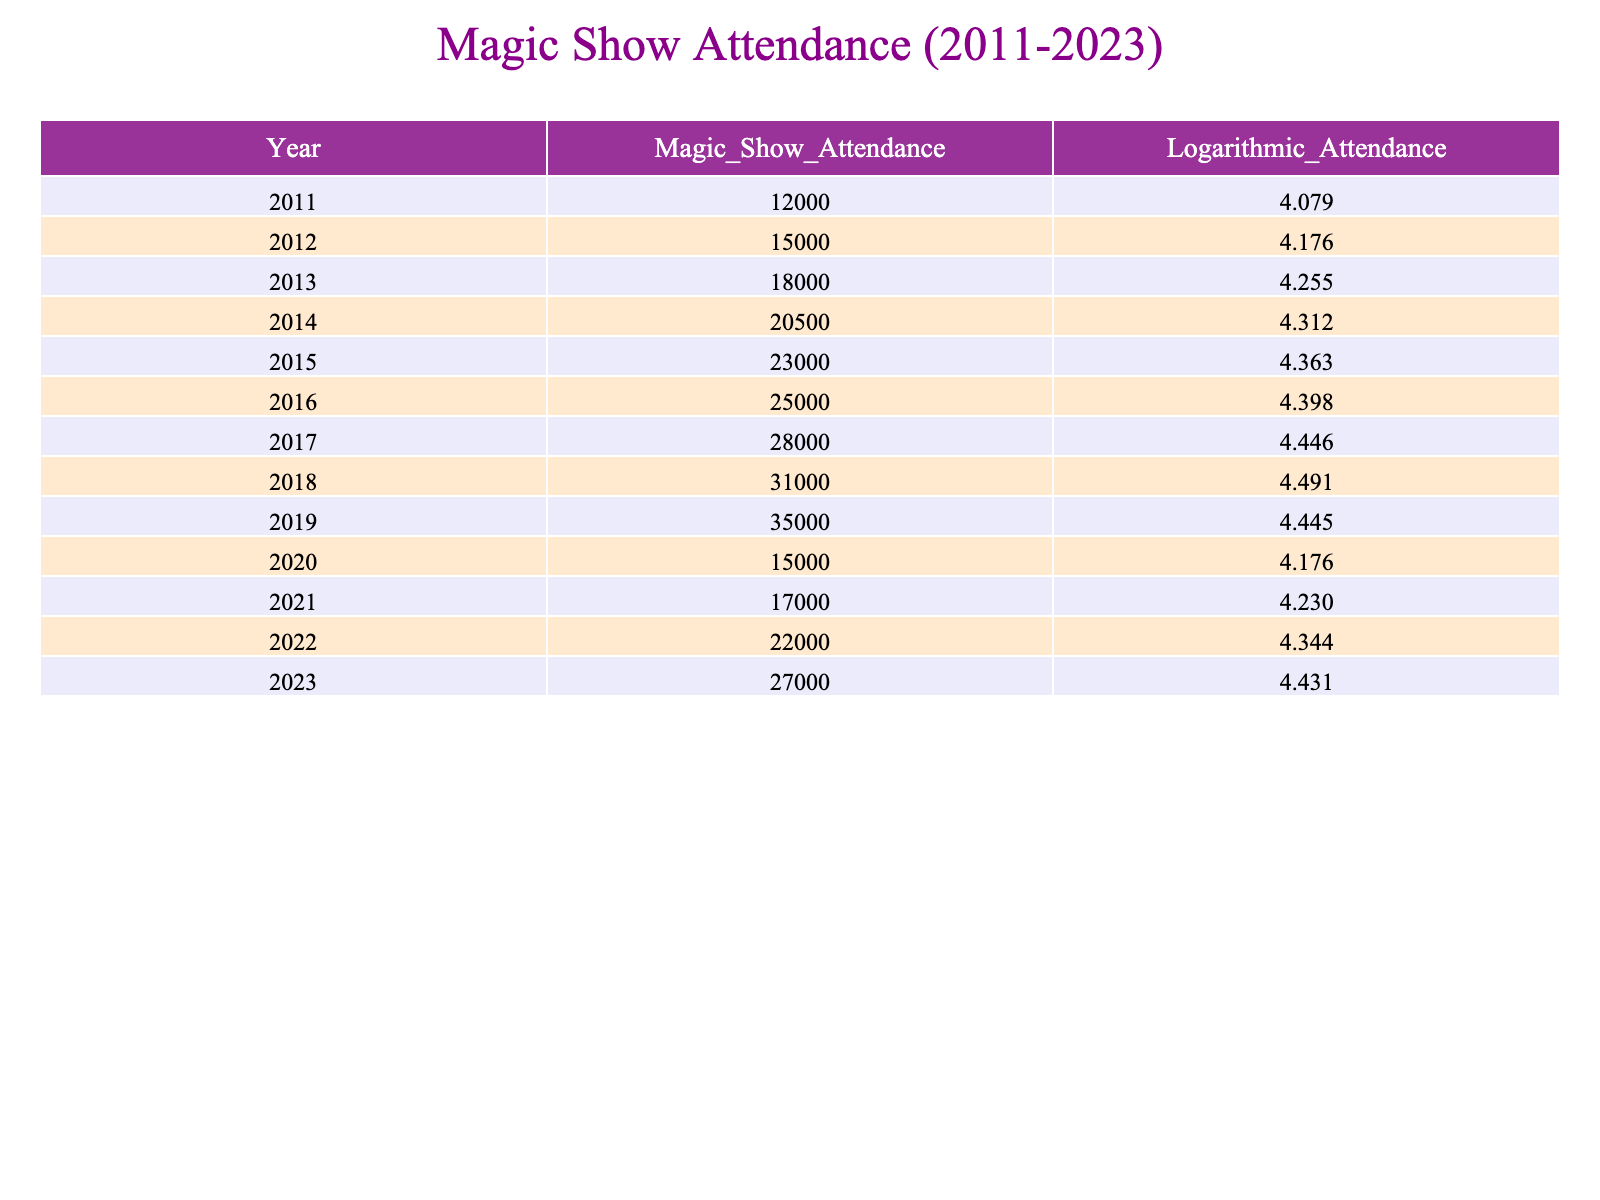What was the magic show attendance in 2013? The table shows attendance for each year. In 2013, the attendance is specifically listed as 18000.
Answer: 18000 What is the logarithmic value of the magic show attendance in 2021? The table provides the logarithmic values next to the attendance for each corresponding year. For 2021, the logarithmic value is given as 4.230449535.
Answer: 4.230 What was the difference in magic show attendance between 2012 and 2015? To find the difference, we subtract the attendance in 2012 (15000) from the attendance in 2015 (23000): 23000 - 15000 = 8000.
Answer: 8000 Is the attendance in 2020 higher than in 2018? The attendance for 2020 is listed as 15000, while for 2018 it is 31000. Since 15000 is less than 31000, the answer is no.
Answer: No What was the average magic show attendance from 2011 to 2023? To calculate the average, we add the attendance values from 2011 (12000) to 2023 (27000), which totals 190000. There are 13 years total, so we divide by 13: 190000 / 13 = 14615.38.
Answer: Approximately 14615 What year shows the highest logarithmic attendance value, and what is that value? By looking at the logarithmic values in the table, the highest value is 4.491361049, which corresponds to the year 2018.
Answer: 2018, 4.491 How many years had magic show attendance lower than 20000? From the table, the attendance values lower than 20000 are for the years 2011 (12000), 2012 (15000), and 2020 (15000). Counting these, we find there are 3 years.
Answer: 3 What was the trend of attendance from 2018 to 2023? By observing the table, attendance increased from 31000 in 2018 to 27000 in 2023, indicating a decrease over these years, despite some variability.
Answer: Decrease What is the total attendance for the three years with the highest attendance? The three highest attendance values are for 2019 (35000), 2018 (31000), and 2017 (28000). Summing these: 35000 + 31000 + 28000 = 94000.
Answer: 94000 